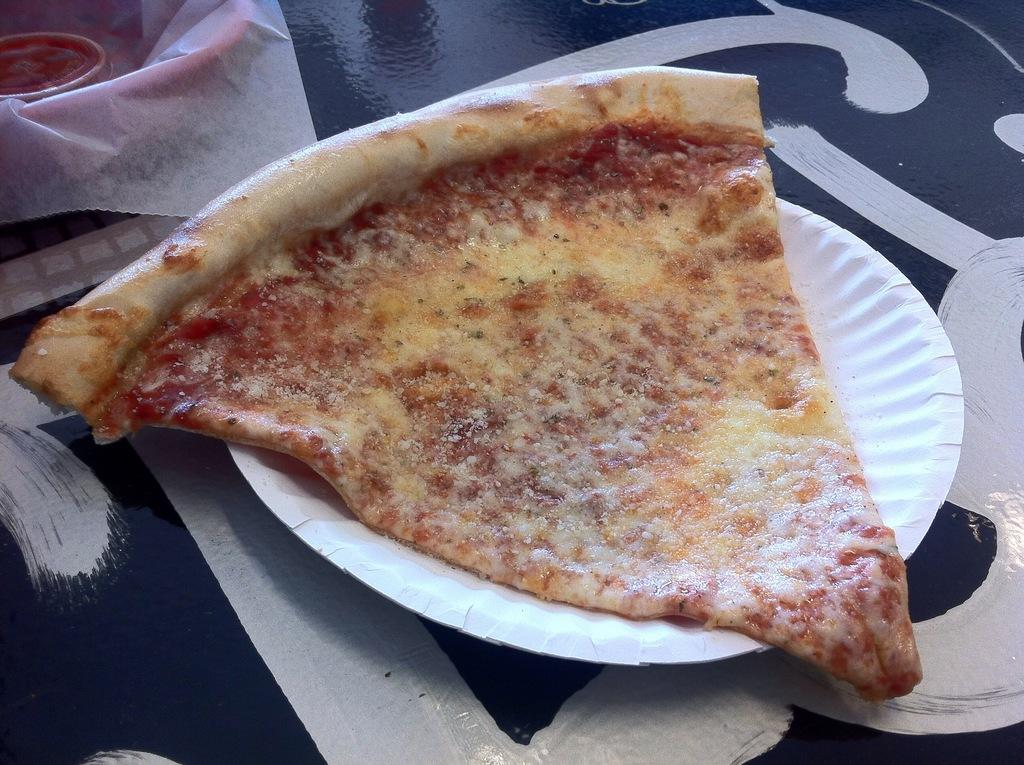What is on the plate in the image? There is a slice of pizza on the plate in the image. What color is the plate? The plate is white. What is present in the top left side of the image? There is a white color paper in the top left side of the image. Can you describe any other items in the image? There are other unspecified things in the image. What theory is being discussed in the image? There is no discussion or theory present in the image; it features a plate with a slice of pizza and a white paper. Is there a desk in the image? There is no desk present in the image. 